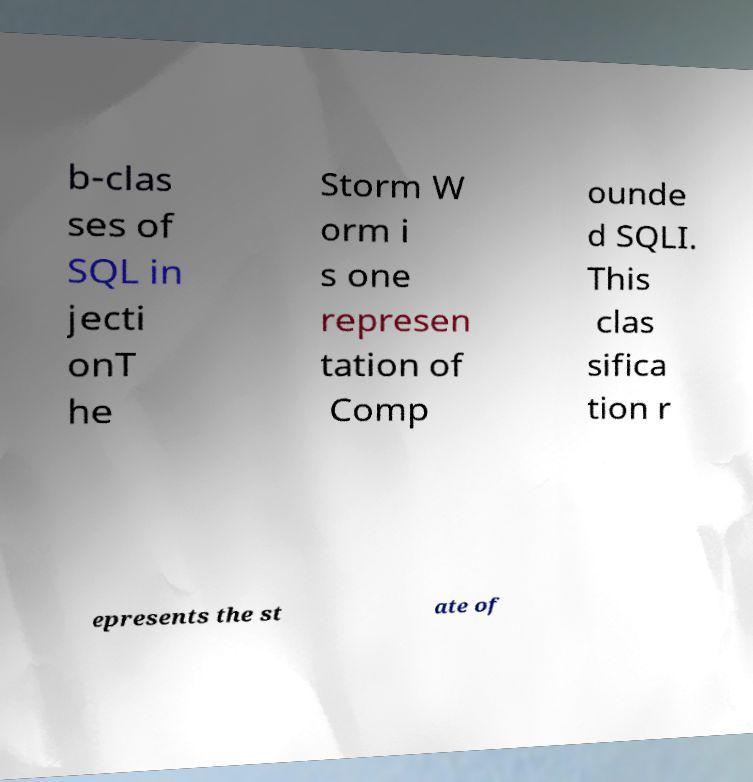Can you accurately transcribe the text from the provided image for me? b-clas ses of SQL in jecti onT he Storm W orm i s one represen tation of Comp ounde d SQLI. This clas sifica tion r epresents the st ate of 